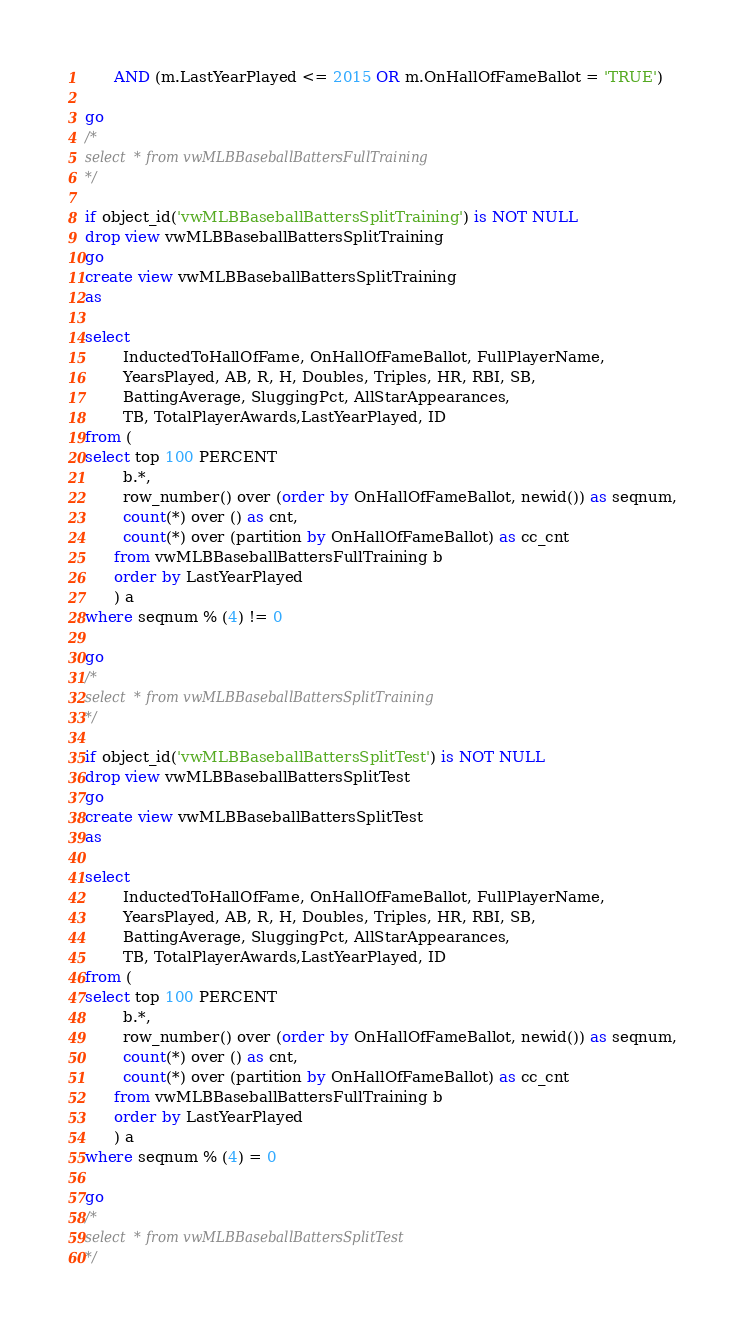Convert code to text. <code><loc_0><loc_0><loc_500><loc_500><_SQL_>	  AND (m.LastYearPlayed <= 2015 OR m.OnHallOfFameBallot = 'TRUE')

go
/*
select * from vwMLBBaseballBattersFullTraining
*/

if object_id('vwMLBBaseballBattersSplitTraining') is NOT NULL
drop view vwMLBBaseballBattersSplitTraining
go
create view vwMLBBaseballBattersSplitTraining
as

select
		InductedToHallOfFame, OnHallOfFameBallot, FullPlayerName, 
		YearsPlayed, AB, R, H, Doubles, Triples, HR, RBI, SB, 
		BattingAverage, SluggingPct, AllStarAppearances,
		TB, TotalPlayerAwards,LastYearPlayed, ID
from (
select top 100 PERCENT
		b.*,
		row_number() over (order by OnHallOfFameBallot, newid()) as seqnum,
		count(*) over () as cnt,
		count(*) over (partition by OnHallOfFameBallot) as cc_cnt
      from vwMLBBaseballBattersFullTraining b
	  order by LastYearPlayed
	  ) a
where seqnum % (4) != 0

go
/*
select * from vwMLBBaseballBattersSplitTraining
*/

if object_id('vwMLBBaseballBattersSplitTest') is NOT NULL
drop view vwMLBBaseballBattersSplitTest
go
create view vwMLBBaseballBattersSplitTest
as

select
		InductedToHallOfFame, OnHallOfFameBallot, FullPlayerName, 
		YearsPlayed, AB, R, H, Doubles, Triples, HR, RBI, SB, 
		BattingAverage, SluggingPct, AllStarAppearances,
		TB, TotalPlayerAwards,LastYearPlayed, ID
from (
select top 100 PERCENT
		b.*,
		row_number() over (order by OnHallOfFameBallot, newid()) as seqnum,
		count(*) over () as cnt,
		count(*) over (partition by OnHallOfFameBallot) as cc_cnt
      from vwMLBBaseballBattersFullTraining b
	  order by LastYearPlayed
	  ) a
where seqnum % (4) = 0

go
/*
select * from vwMLBBaseballBattersSplitTest
*/</code> 